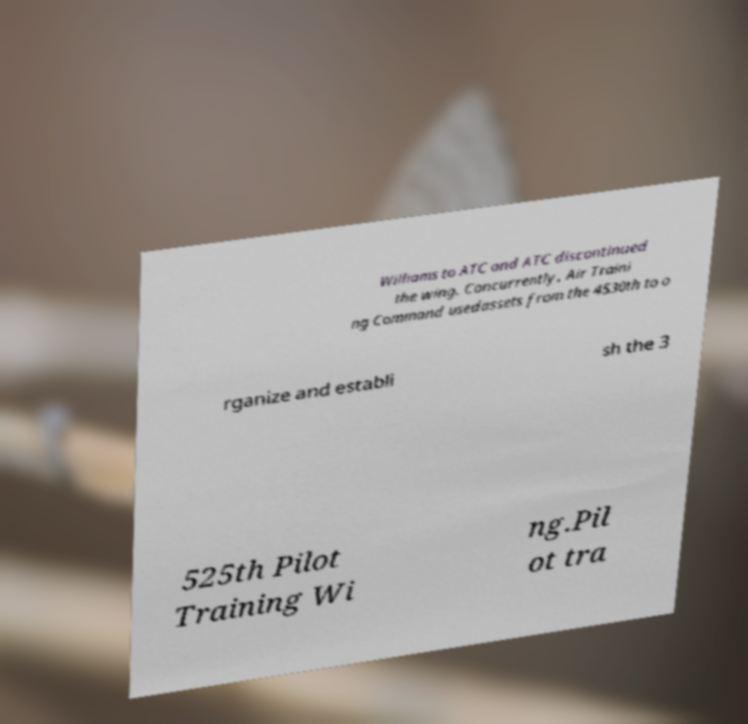What messages or text are displayed in this image? I need them in a readable, typed format. Williams to ATC and ATC discontinued the wing. Concurrently, Air Traini ng Command usedassets from the 4530th to o rganize and establi sh the 3 525th Pilot Training Wi ng.Pil ot tra 